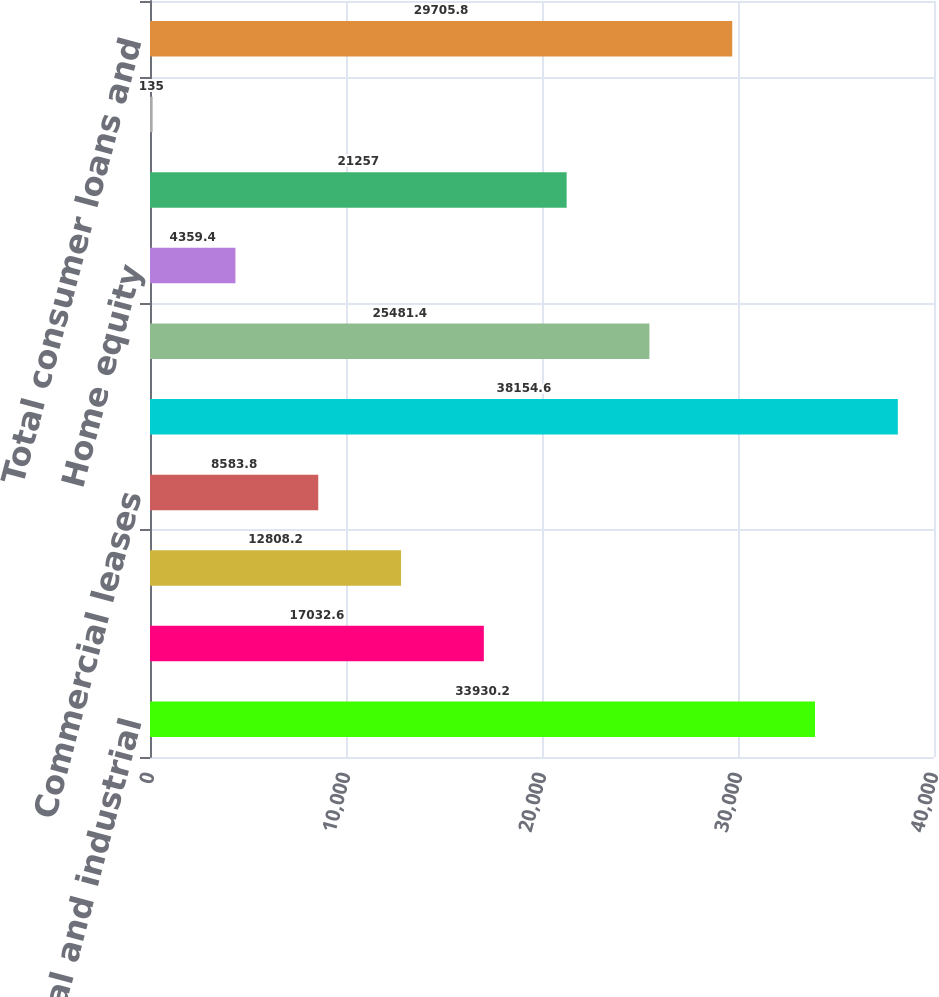Convert chart to OTSL. <chart><loc_0><loc_0><loc_500><loc_500><bar_chart><fcel>Commercial and industrial<fcel>Commercial mortgage loans<fcel>Commercial construction loans<fcel>Commercial leases<fcel>Total commercial loans and<fcel>Residential mortgage loans<fcel>Home equity<fcel>Automobile loans<fcel>Other consumer loans and<fcel>Total consumer loans and<nl><fcel>33930.2<fcel>17032.6<fcel>12808.2<fcel>8583.8<fcel>38154.6<fcel>25481.4<fcel>4359.4<fcel>21257<fcel>135<fcel>29705.8<nl></chart> 